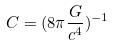<formula> <loc_0><loc_0><loc_500><loc_500>C = ( 8 \pi \frac { G } { c ^ { 4 } } ) ^ { - 1 }</formula> 